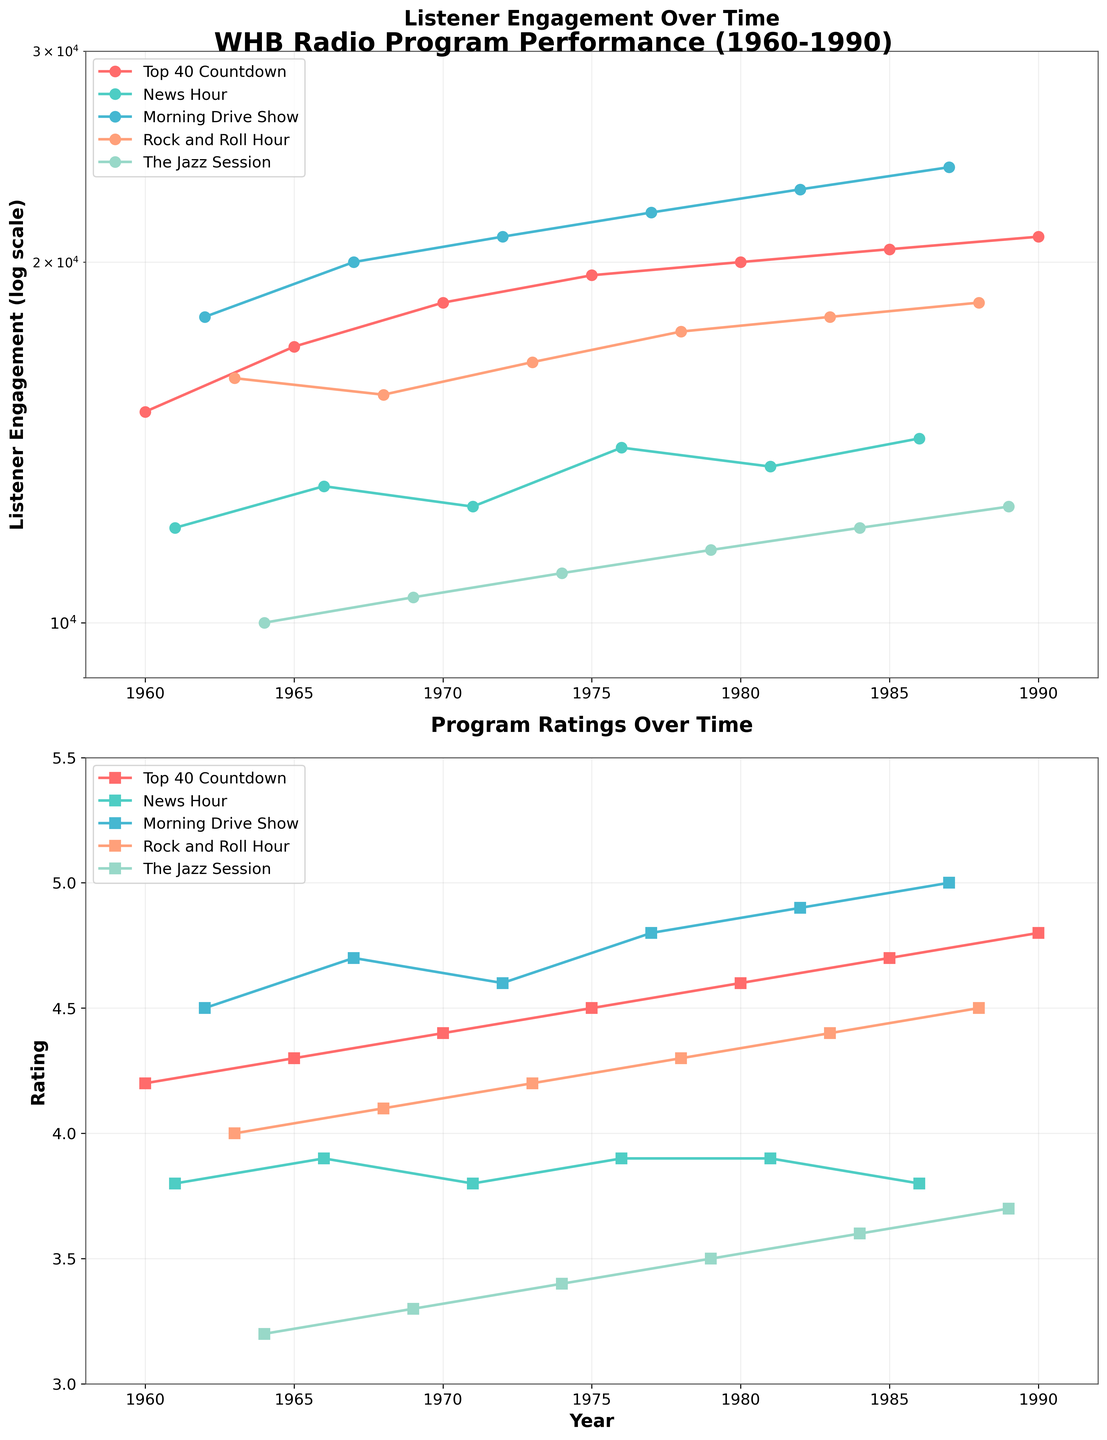What is the title of the figure? The title is usually located at the top of the figure and summarizes the content of the plots. In this case, the title is "WHB Radio Program Performance (1960-1990)" based on the description of the code.
Answer: WHB Radio Program Performance (1960-1990) What is the y-axis label of the first subplot? The y-axis label of the first subplot is shown on the left side of the plot. According to the provided code, it is "Listener Engagement (log scale)".
Answer: Listener Engagement (log scale) Which program had the highest listener engagement in 1972? By checking the 'Listener Engagement' data for the year 1972 and looking at the first subplot, we see that the "Morning Drive Show" had the highest engagement with 21,000 listeners.
Answer: Morning Drive Show Which program has the lowest rating in 1984? By checking the 'Rating' data for the year 1984 and looking at the second subplot, "The Jazz Session" had the lowest rating with a value of 3.6.
Answer: The Jazz Session What is the trend of listener engagement for the "Top 40 Countdown" from 1960 to 1990? Observing the 'Top 40 Countdown' data points in the first subplot, the listener engagement generally increases over the years from 1960 to 1990.
Answer: Increasing Compare the ratings of "News Hour" and "Rock and Roll Hour" in 1973. Which one had a higher rating? By referring to the second subplot and the 'Rating' data for 1973, "Rock and Roll Hour" had a higher rating (4.2) compared to "News Hour" (3.8).
Answer: Rock and Roll Hour What is the average listener engagement for all programs in 1980? In 1980, listener engagements are: 20,000 (Top 40 Countdown), 13,500 (News Hour), 23,000 (Morning Drive Show), 18,000 (Rock and Roll Hour), and 12,000 (The Jazz Session). The average = (20000 + 13500 + 23000 + 18000 + 12000) / 5 = 16,700.
Answer: 16,700 Identify the program with the highest rating throughout the entire period from 1960 to 1990. By checking the second subplot for the highest rating point, "Morning Drive Show" had the highest rating with 5.0 in 1987.
Answer: Morning Drive Show How does the listener engagement of "The Jazz Session" change from 1964 to 1974? Observing the first subplot, "The Jazz Session" listener engagement increases slightly from 10,000 in 1964 to 11,000 in 1974.
Answer: Slight increase What was the listener engagement for "Morning Drive Show" in the year it had the highest rating? In the second subplot, "Morning Drive Show" had its highest rating of 5.0 in 1987, and the first subplot shows that the listener engagement in that year was 24,000.
Answer: 24,000 